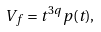Convert formula to latex. <formula><loc_0><loc_0><loc_500><loc_500>V _ { f } = t ^ { 3 q } p ( t ) ,</formula> 